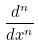Convert formula to latex. <formula><loc_0><loc_0><loc_500><loc_500>\frac { d ^ { n } } { d x ^ { n } }</formula> 